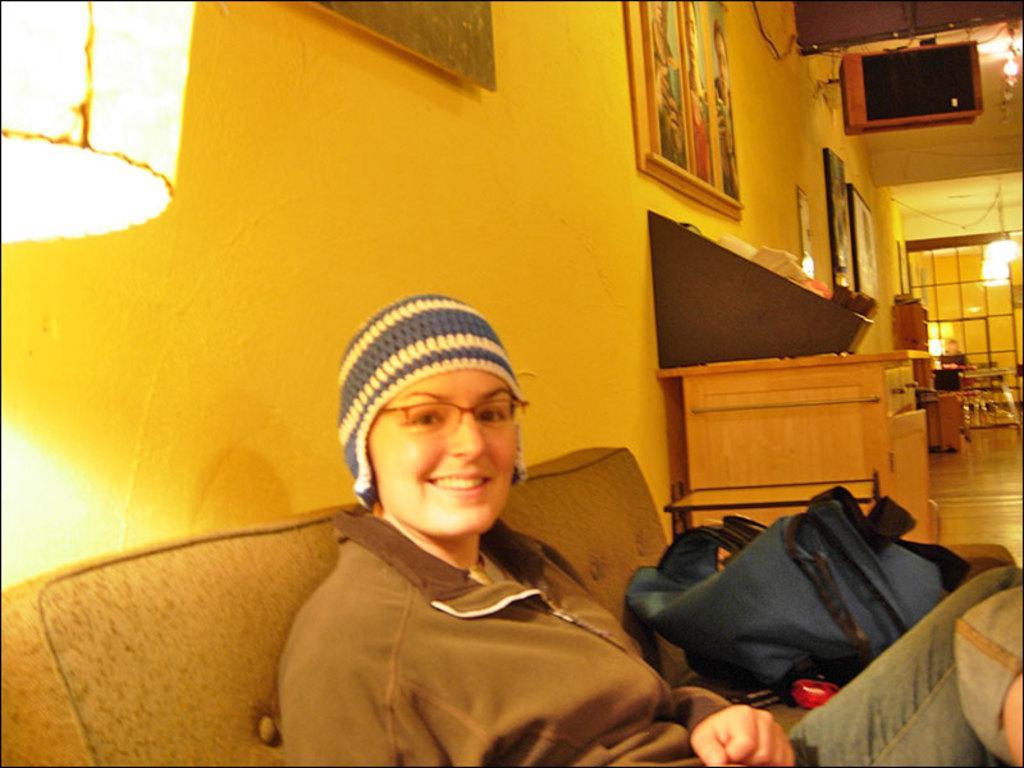Please provide a concise description of this image. This is the picture of a room. In this image there is a woman sitting on the sofa and she is smiling and there is bag on the sofa. At the back there is an object on the table. There are frames on the wall. On the left side of the image there is a light. At the top there is an object and there are lights. At the back there is a glass door. At the bottom there is a floor. 